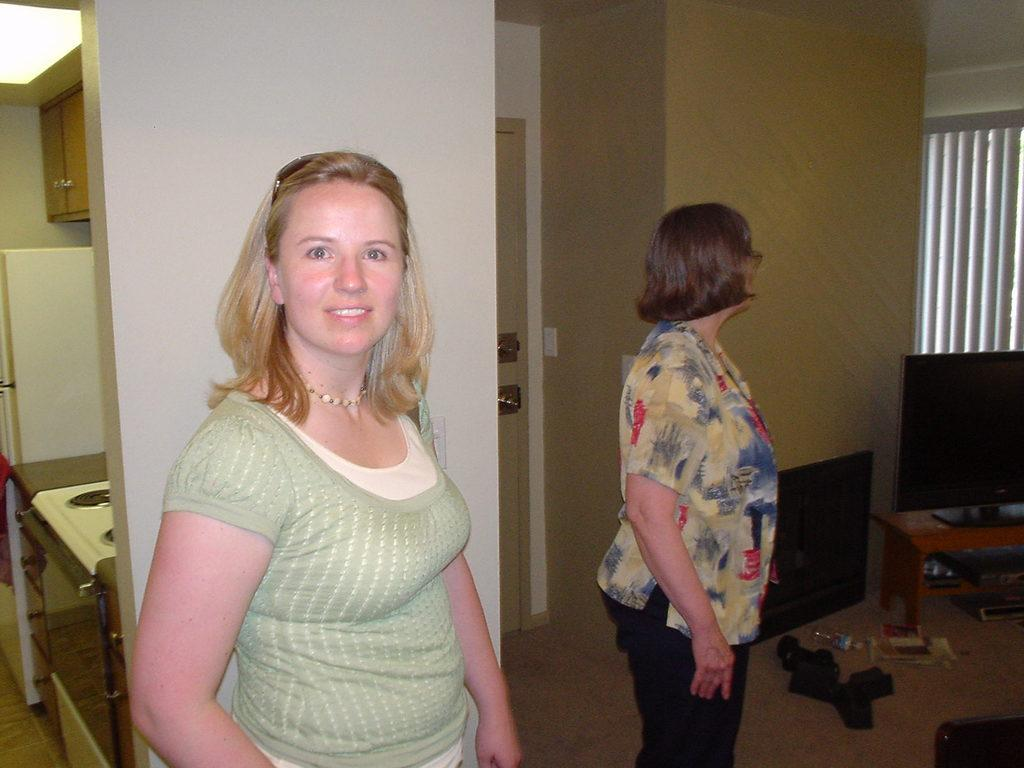How many people are in the image? There are two people standing in the image. What are the people wearing? The people are wearing different color dresses. What can be seen in the background of the image? There is a table, a wall, a window, cupboards, and a stove in the background of the image. What type of advertisement can be seen on the wall in the image? There is no advertisement present on the wall in the image. Can you tell me how many cows are visible through the window in the image? There are no cows visible through the window in the image. 